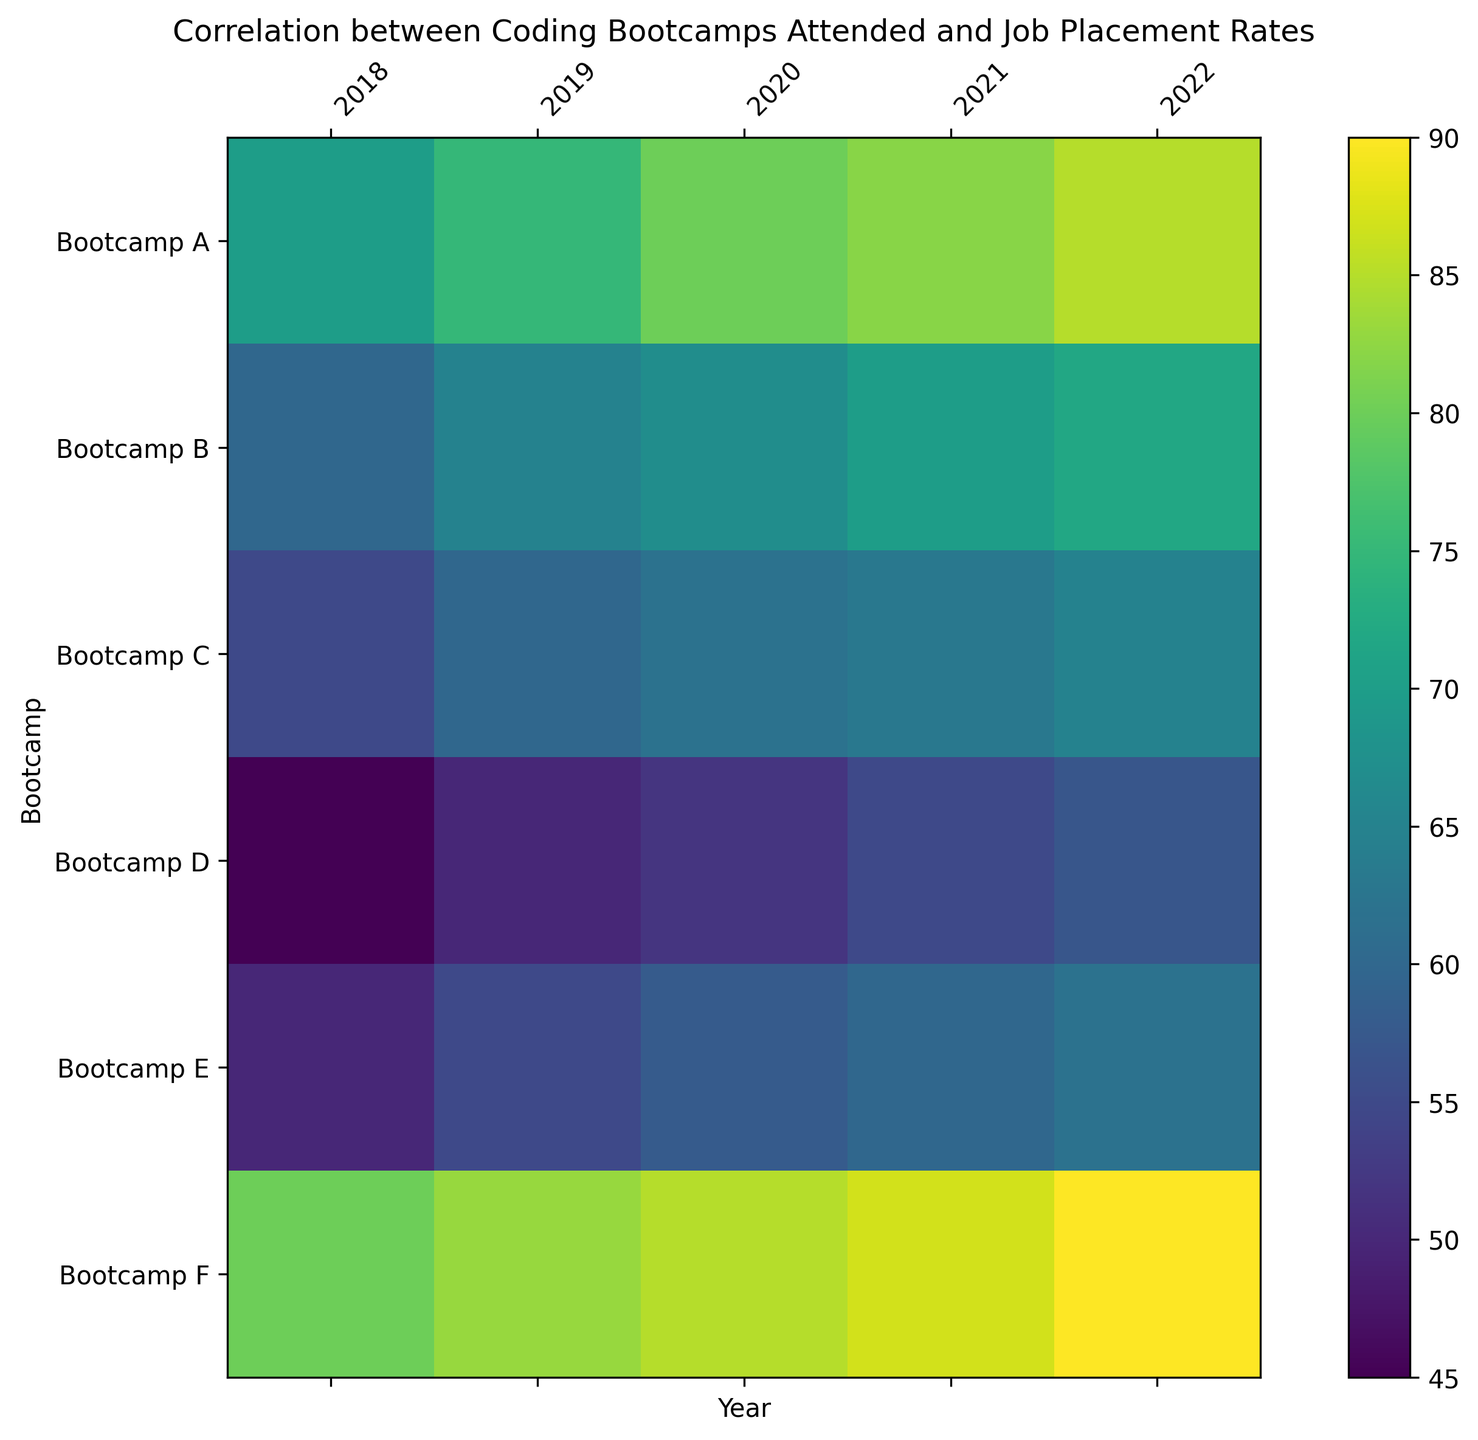What's the trend of job placement rates for Bootcamp A over the years? To determine the trend, observe the color gradient and values for Bootcamp A across the years from 2018 to 2022. The heatmap shows increasing values for Bootcamp A from 70 in 2018 to 85 in 2022, indicating an upward trend.
Answer: Upward trend Which bootcamp had the highest job placement rate in 2022? By looking at the color gradient and the values for the year 2022, Bootcamp F has the darkest color, corresponding to the highest value of 90.
Answer: Bootcamp F How did Bootcamp D's job placement rate change from 2018 to 2022? Evaluate the values and color changes from 2018 (45) to 2022 (57) for Bootcamp D. The increase from 45 to 57 signifies an upward change by 12 units.
Answer: Increased by 12 Which bootcamp exhibited the least improvement in job placement rates from 2018 to 2022? Calculate the differences for each bootcamp from 2018 to 2022: Bootcamp A (85-70=15), Bootcamp B (72-60=12), Bootcamp C (65-55=10), Bootcamp D (57-45=12), Bootcamp E (62-50=12), Bootcamp F (90-80=10). Bootcamp C and Bootcamp F both show the smallest improvement of 10 units.
Answer: Bootcamp C and Bootcamp F What was the average job placement rate among all bootcamps in 2020? Sum the 2020 values for all bootcamps: 80 + 67 + 62 + 52 + 58 + 85 = 404. Divide by the number of bootcamps (6): 404 / 6 ≈ 67.33.
Answer: 67.33 Which bootcamps had a job placement rate exceeding 60 in 2018 and 70 in 2022? Match bootcamps that meet both criteria: Bootcamp A (2018: 70, 2022: 85), Bootcamp F (2018: 80, 2022: 90).
Answer: Bootcamp A and Bootcamp F Compare Bootcamp B and Bootcamp E's job placement rates in 2019. Which was higher? Analyze the values for 2019: Bootcamp B is 65, Bootcamp E is 55. Bootcamp B's rate is higher at 65.
Answer: Bootcamp B What is the range of job placement rates for Bootcamp F over the five years? Identify the minimum (80 in 2018) and maximum (90 in 2022) values for Bootcamp F. The range is calculated by subtracting the minimum from the maximum: 90 - 80 = 10.
Answer: 10 What is the median job placement rate for Bootcamp C across the years? List Bootcamp C's values from 2018 to 2022: (55, 60, 62, 63, 65). The median is the middle value in the ordered list, which is 62.
Answer: 62 